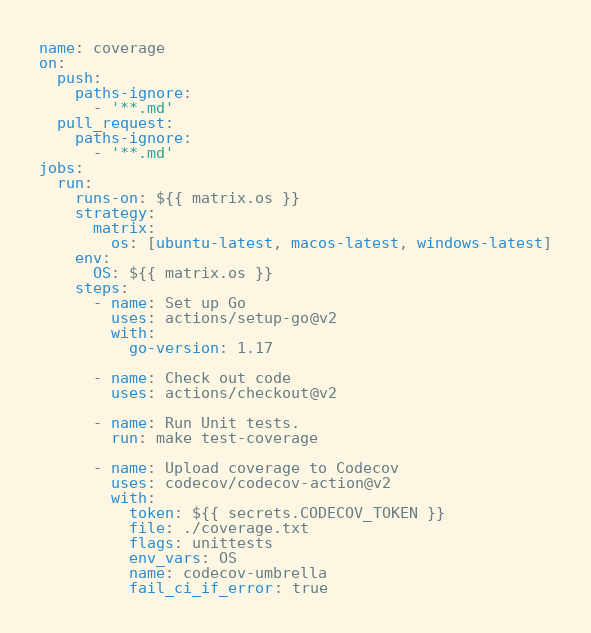<code> <loc_0><loc_0><loc_500><loc_500><_YAML_>name: coverage
on:
  push:
    paths-ignore:
      - '**.md'
  pull_request:
    paths-ignore:
      - '**.md'
jobs:
  run:
    runs-on: ${{ matrix.os }}
    strategy:
      matrix:
        os: [ubuntu-latest, macos-latest, windows-latest]
    env:
      OS: ${{ matrix.os }}
    steps:
      - name: Set up Go
        uses: actions/setup-go@v2
        with:
          go-version: 1.17

      - name: Check out code
        uses: actions/checkout@v2

      - name: Run Unit tests.
        run: make test-coverage

      - name: Upload coverage to Codecov
        uses: codecov/codecov-action@v2
        with:
          token: ${{ secrets.CODECOV_TOKEN }}
          file: ./coverage.txt
          flags: unittests
          env_vars: OS
          name: codecov-umbrella
          fail_ci_if_error: true
</code> 